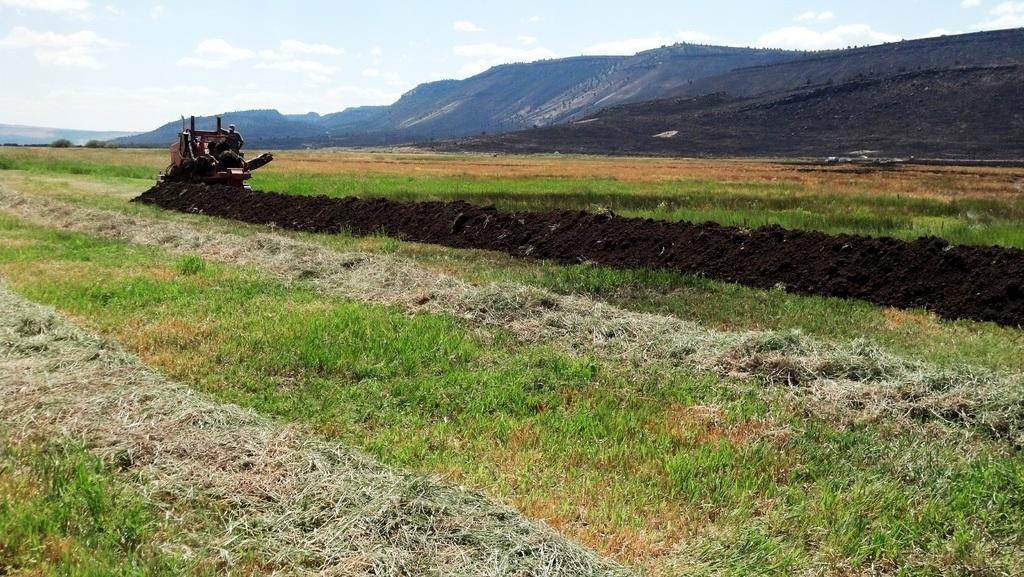What type of terrain is visible on the ground in the image? There is green grass on the ground in the image. What is located in the middle of the image? There is a vehicle in the middle of the image. What can be seen in the distance in the image? There are mountains in the background of the image. What is visible in the sky at the top of the image? There are clouds visible in the sky at the top of the image. What type of badge is the vehicle wearing in the image? There is no badge present on the vehicle in the image. What type of suit is the mountain wearing in the image? There is no suit present on the mountain in the image; it is a natural geological formation. 